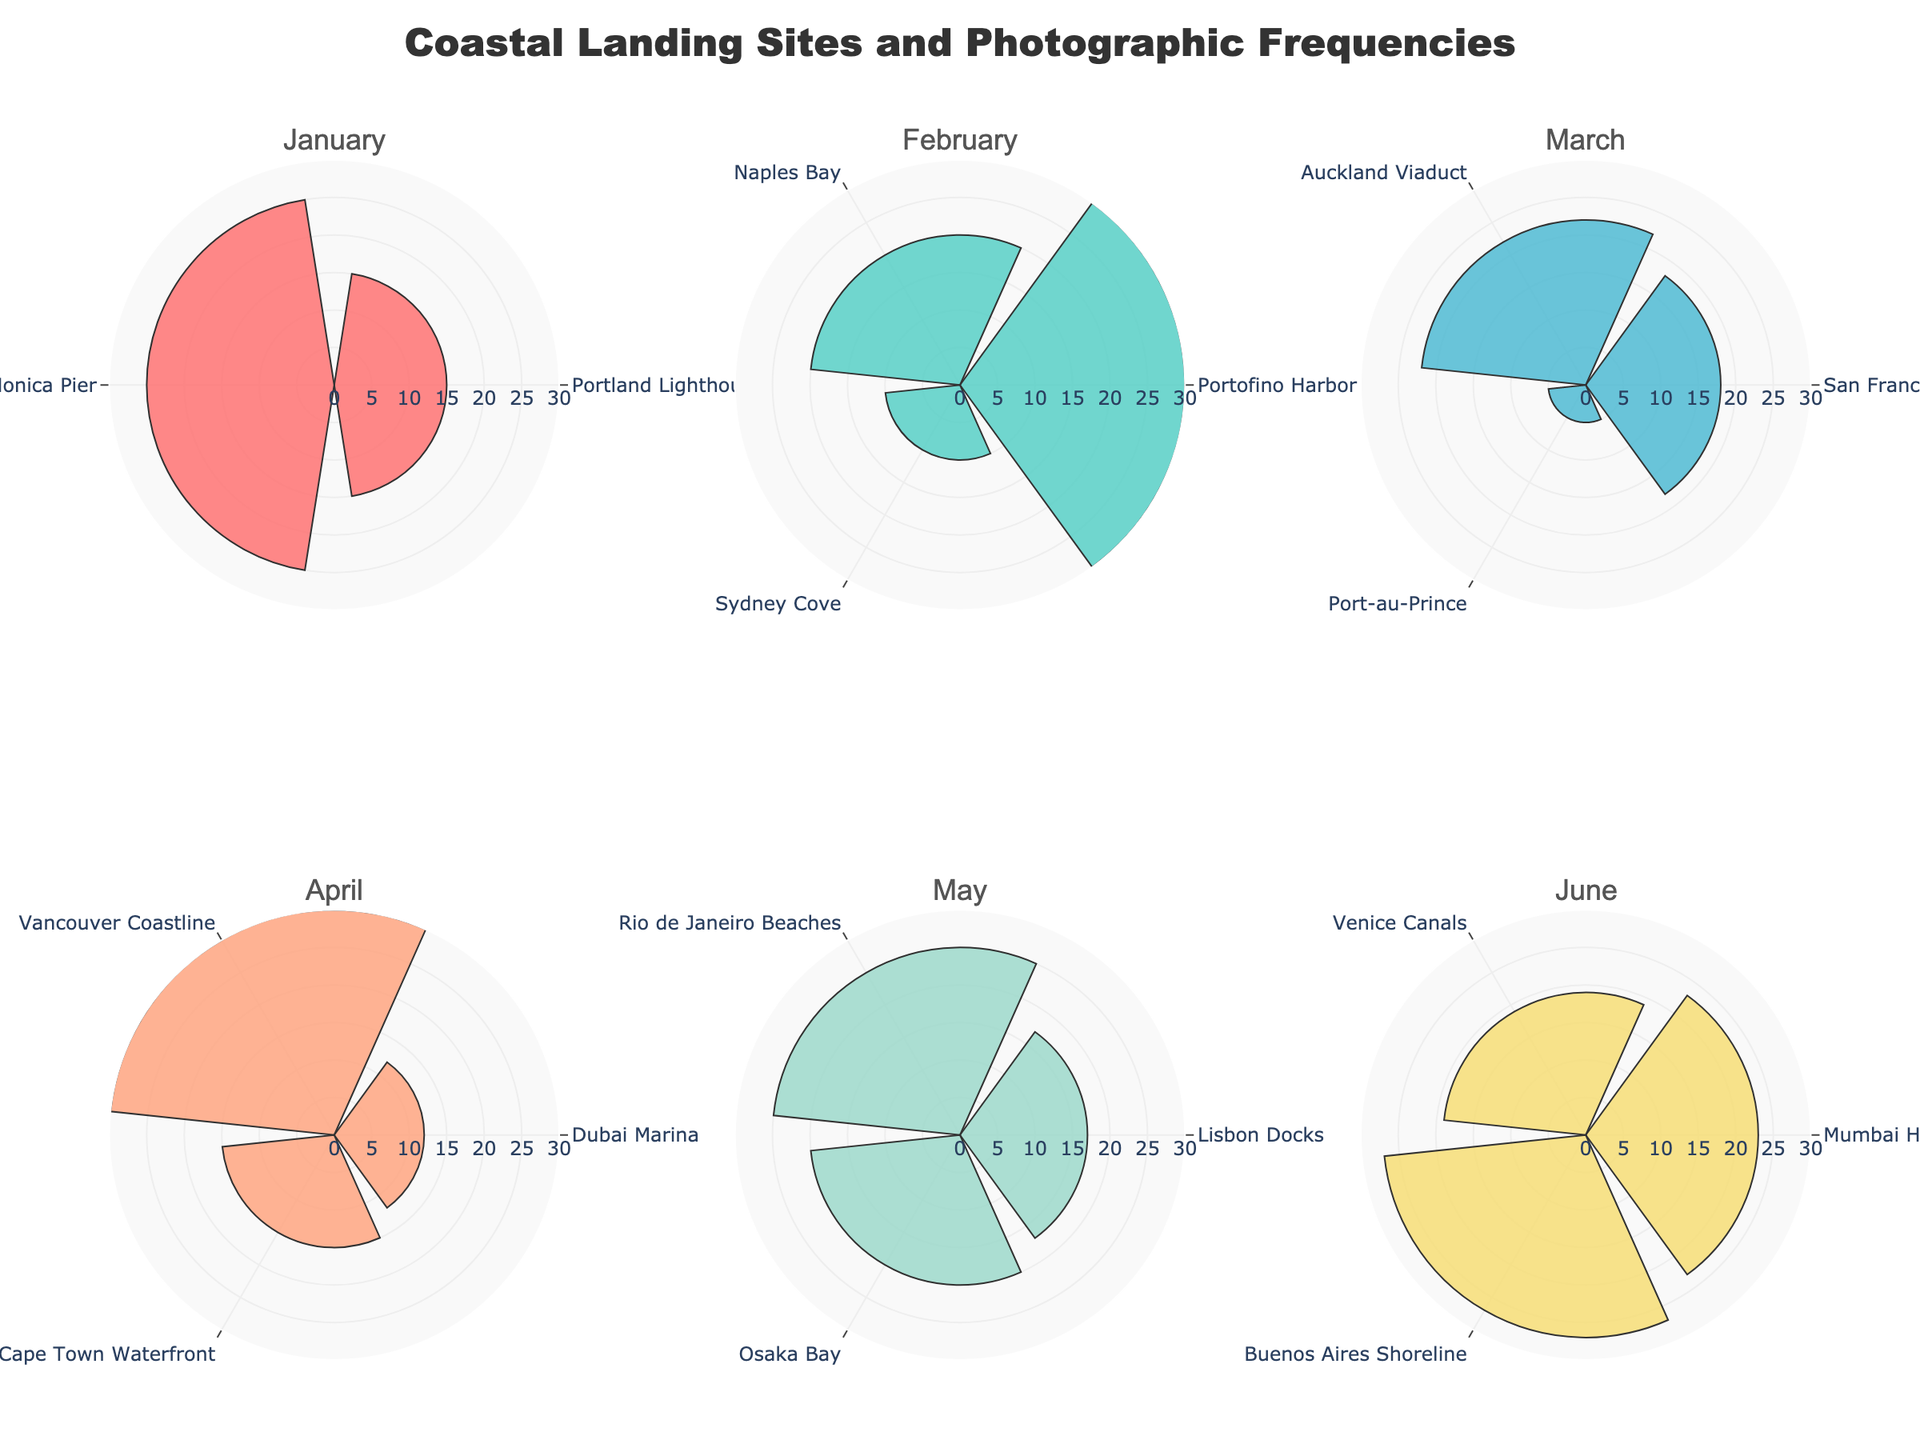what is the color of the bars for March? In the subplot for March, each barpolar chart has a specific color according to the predefined custom color palette. From inspecting the figure, we can see that the bars for March are colored with a specific color in the list.
Answer: #4ECDC4 (greenish-cyan) How many landing sites were documented in April? We can count the number of bars in the subplot for April to determine the number of landing sites documented. Each bar represents a different landing site. There are three bars visible.
Answer: 3 Which month had the highest frequency of photographs at any landing site? To find the highest frequency of photographs, we need to compare the peak values of the radial axis for each subplot. By inspecting the figure, we notice that the Vancouver Coastline in April has the highest frequency at 30.
Answer: April What is the total number of photographs taken in May? To find the total number of photographs taken in May, we sum the frequencies for all landing sites in the May subplot. The sites are Lisbon Docks (17), Rio de Janeiro Beaches (25), and Osaka Bay (20). Adding these gives 17 + 25 + 20.
Answer: 62 Which landing site had the least number of photographs in March? To find the landing site with the least number of photographs in March, we examine the length of the bars in the subplot for March. The shortest bar represents Port-au-Prince with 5 photographs.
Answer: Port-au-Prince What is the difference in photographic frequency between the landing sites with the highest and lowest frequencies in June? In June, the highest frequency site is Buenos Aires Shoreline with 27 photographs, and the lowest is Venice Canals with 19 photographs. The difference is 27 - 19.
Answer: 8 For which month were the photograpic frequencies of the landing sites almost equally distributed? By looking at the figure, we need to identify the month where the bars (frequencies) appear almost the same length. Both May and March exhibit relatively evenly distributed frequencies, but March is more distinct with values closer to each other.
Answer: March 